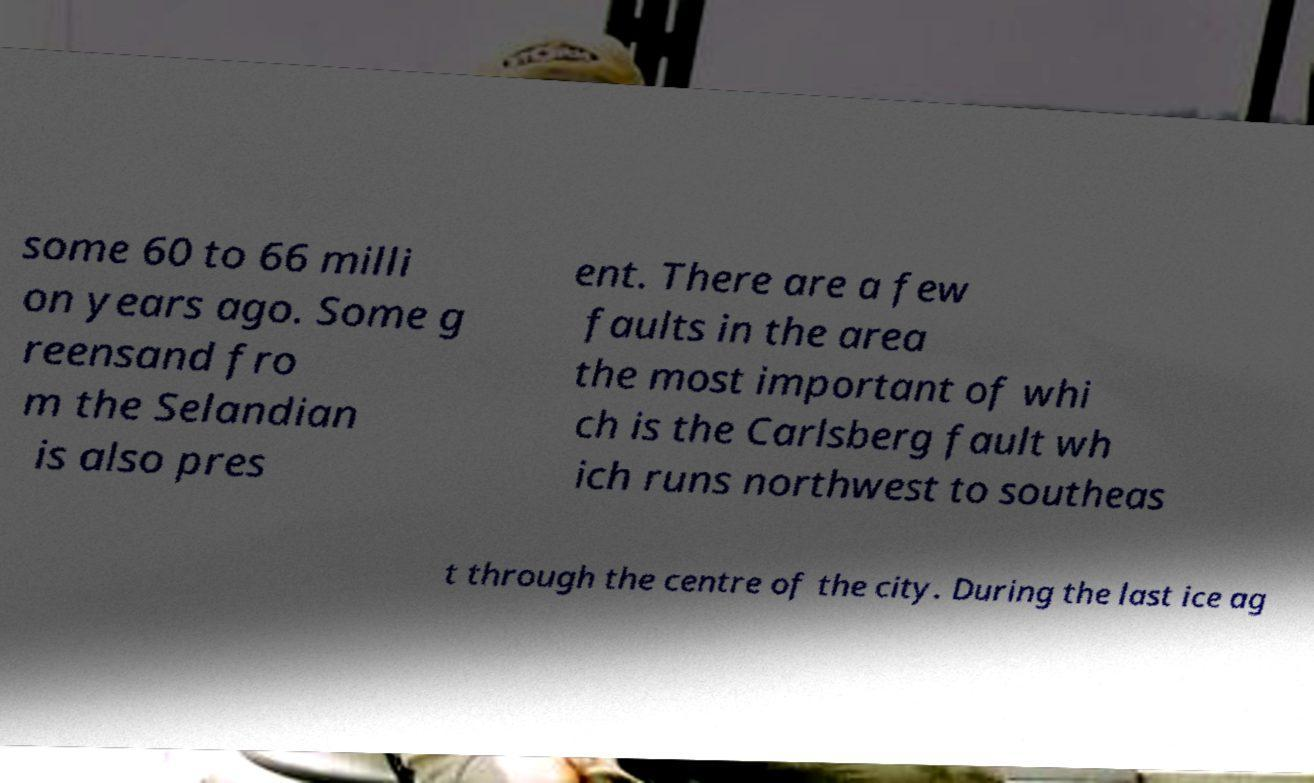For documentation purposes, I need the text within this image transcribed. Could you provide that? some 60 to 66 milli on years ago. Some g reensand fro m the Selandian is also pres ent. There are a few faults in the area the most important of whi ch is the Carlsberg fault wh ich runs northwest to southeas t through the centre of the city. During the last ice ag 